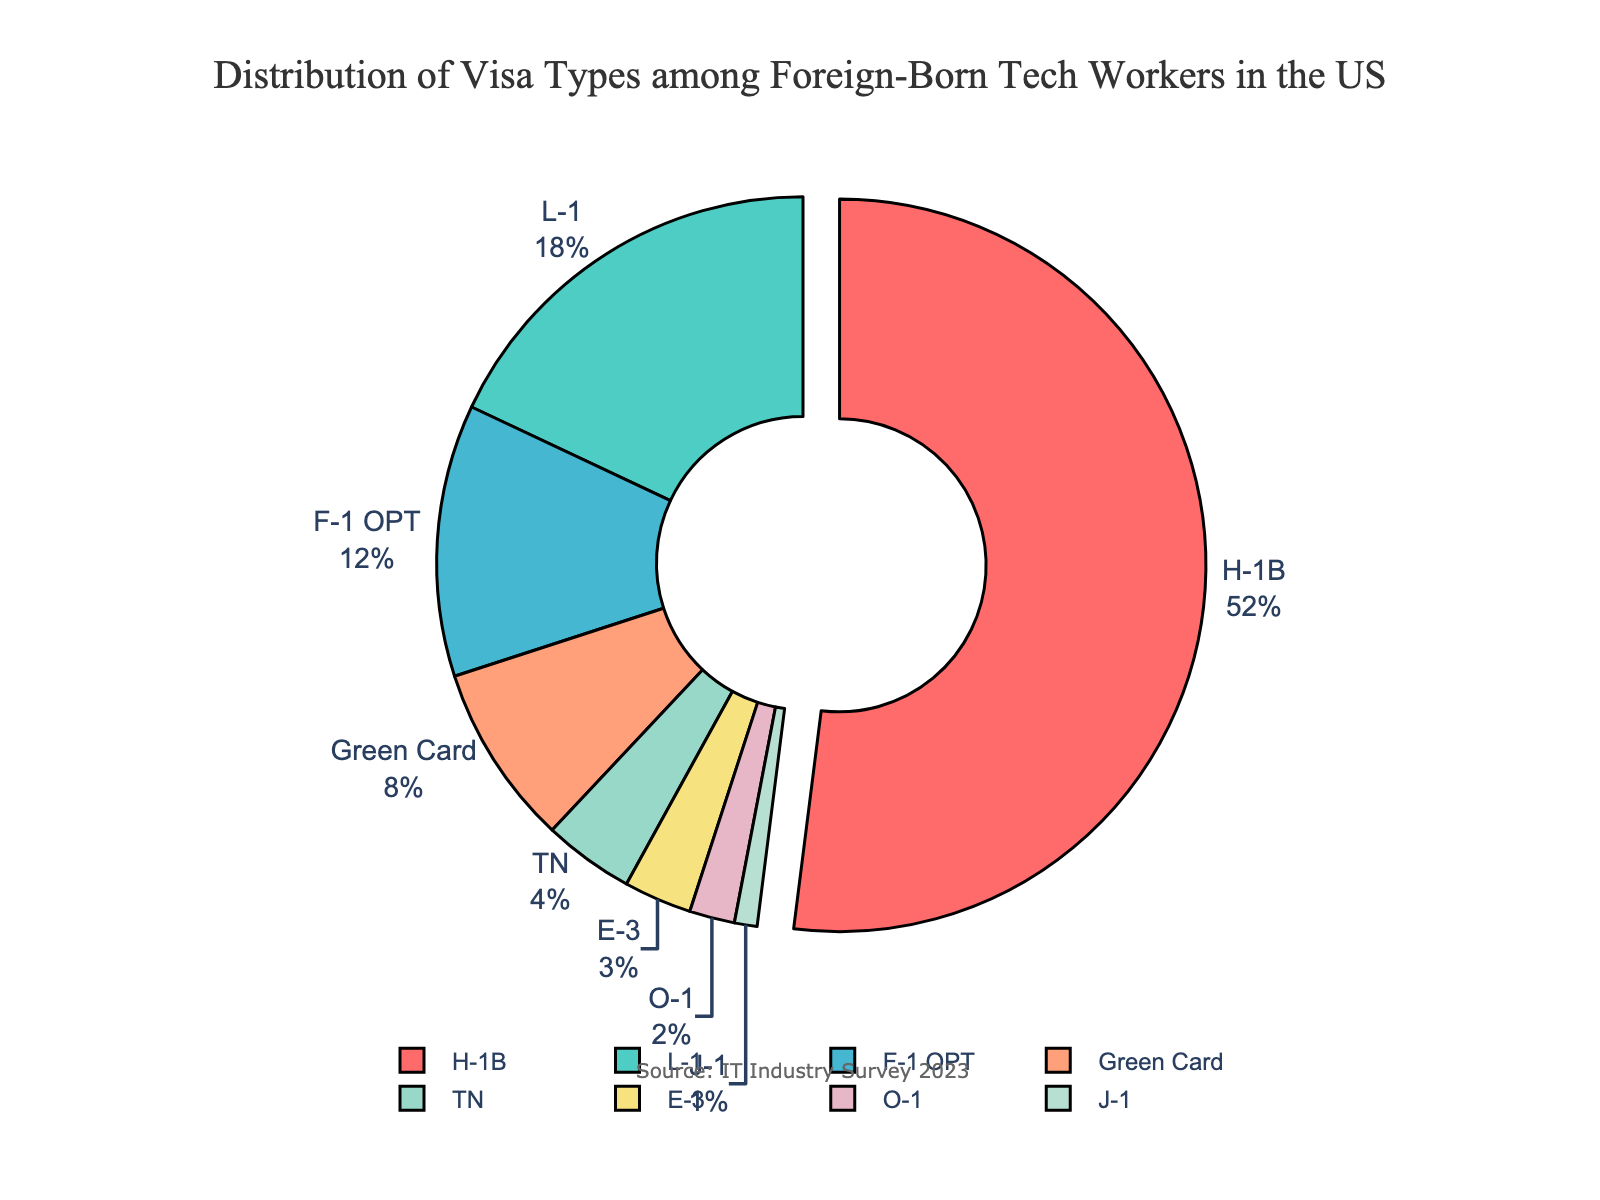what is the most common visa type among foreign-born tech workers in the US according to the chart? The pie chart shows different visa types by percentage. The H-1B visa has the largest slice and its label shows 52%, which is the highest percentage.
Answer: H-1B Which visa type has the smallest representation among foreign-born tech workers in the US? The smallest slice in the pie chart represents the J-1 visa, and the label shows 1%, indicating it has the smallest representation.
Answer: J-1 What is the combined percentage of H-1B and L-1 visa holders? The percentage for H-1B is 52%, and for L-1 it's 18%. Adding them together (52 + 18) gives a combined percentage.
Answer: 70% How does the percentage of F-1 OPT visa holders compare to that of E-3 visa holders? The percentage for F-1 OPT is 12%, while E-3 has 3%. Comparing these, we see that F-1 OPT is greater than E-3.
Answer: F-1 OPT is greater than E-3 What percentage of foreign-born tech workers hold either a TN or an O-1 visa? The chart shows TN at 4% and O-1 at 2%. Adding these percentages (4 + 2), we get the total percentage for both visa types.
Answer: 6% If the percentages of L-1, F-1 OPT, and Green Card holders are combined, does their total exceed that of H-1B visa holders? Adding the percentages for L-1 (18%), F-1 OPT (12%), and Green Card (8%) gives a total of (18 + 12 + 8) 38%. H-1B has 52%. Since 38% < 52%, their combined total does not exceed H-1B.
Answer: No Which visa types are represented in the pie chart using green shades? By examining the shades of color used in the pie chart, we notice the green shades are applied to the slices labeled L-1 (18%) and TN (4%).
Answer: L-1 and TN What is the difference in percentage points between the H-1B visa and Green Card holders? The H-1B visa holders make up 52%, and Green Card holders make up 8%. Subtracting these (52 - 8), we find the percentage point difference.
Answer: 44% Does the total percentage of J-1 and O-1 visa holders equal that of E-3 visa holders? J-1 holders are at 1% and O-1 holders are at 2%. Adding these together (1 + 2) results in 3%, which is equal to the percentage of E-3 visa holders.
Answer: Yes Which visa types have a percentage greater than 10%? Referring to the percentages displayed in the chart: H-1B (52%) and L-1 (18%), and F-1 OPT (12%), all of which are greater than 10%.
Answer: H-1B, L-1, F-1 OPT 